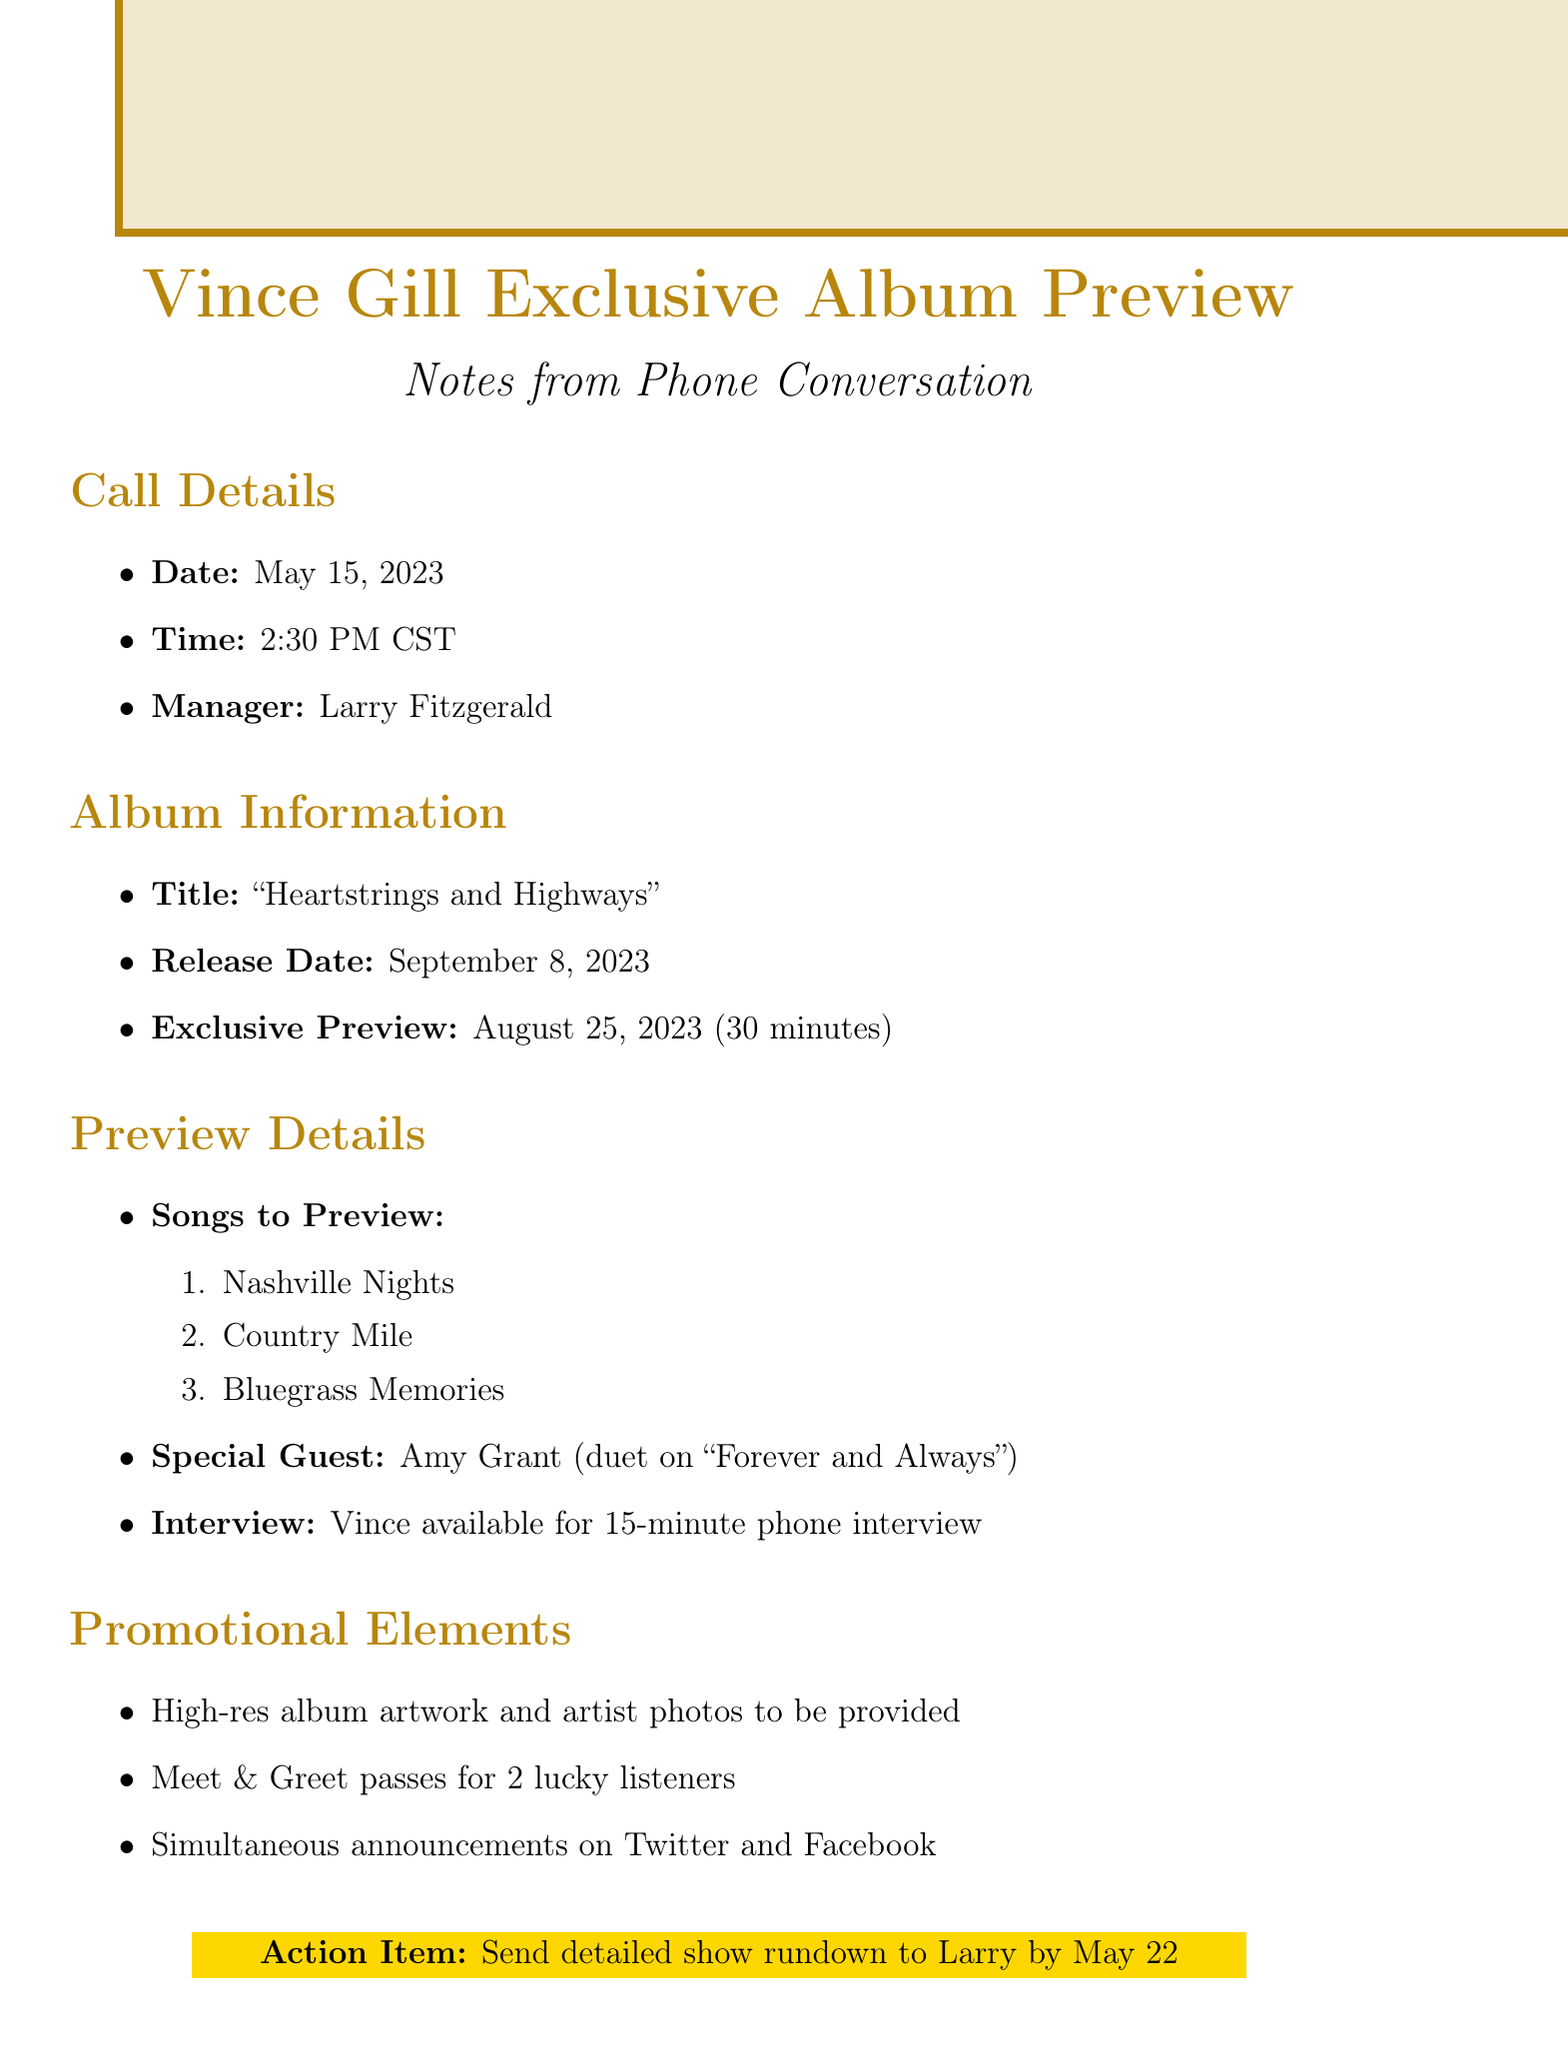What is the date of the call? The date of the call is specified in the document as May 15, 2023.
Answer: May 15, 2023 Who is the manager of Vince Gill? The document mentions Larry Fitzgerald as Vince Gill's manager.
Answer: Larry Fitzgerald What is the title of the album? The title of the album is provided in the document as "Heartstrings and Highways".
Answer: "Heartstrings and Highways" When will the exclusive preview occur? The exclusive preview date is indicated in the document as August 25, 2023.
Answer: August 25, 2023 How long will the album preview last? The document specifies the preview duration as 30 minutes.
Answer: 30 minutes What is the name of the special guest for the preview? The special guest noted in the document is Amy Grant.
Answer: Amy Grant How many songs will be previewed? The document lists three songs to be previewed, indicating the total.
Answer: 3 songs What action is to be completed by May 22? The document states that a detailed show rundown needs to be sent to Larry by May 22.
Answer: Send detailed show rundown Is Vince available for an interview? The document confirms that Vince is available for a 15-minute phone interview.
Answer: 15-minute phone interview 